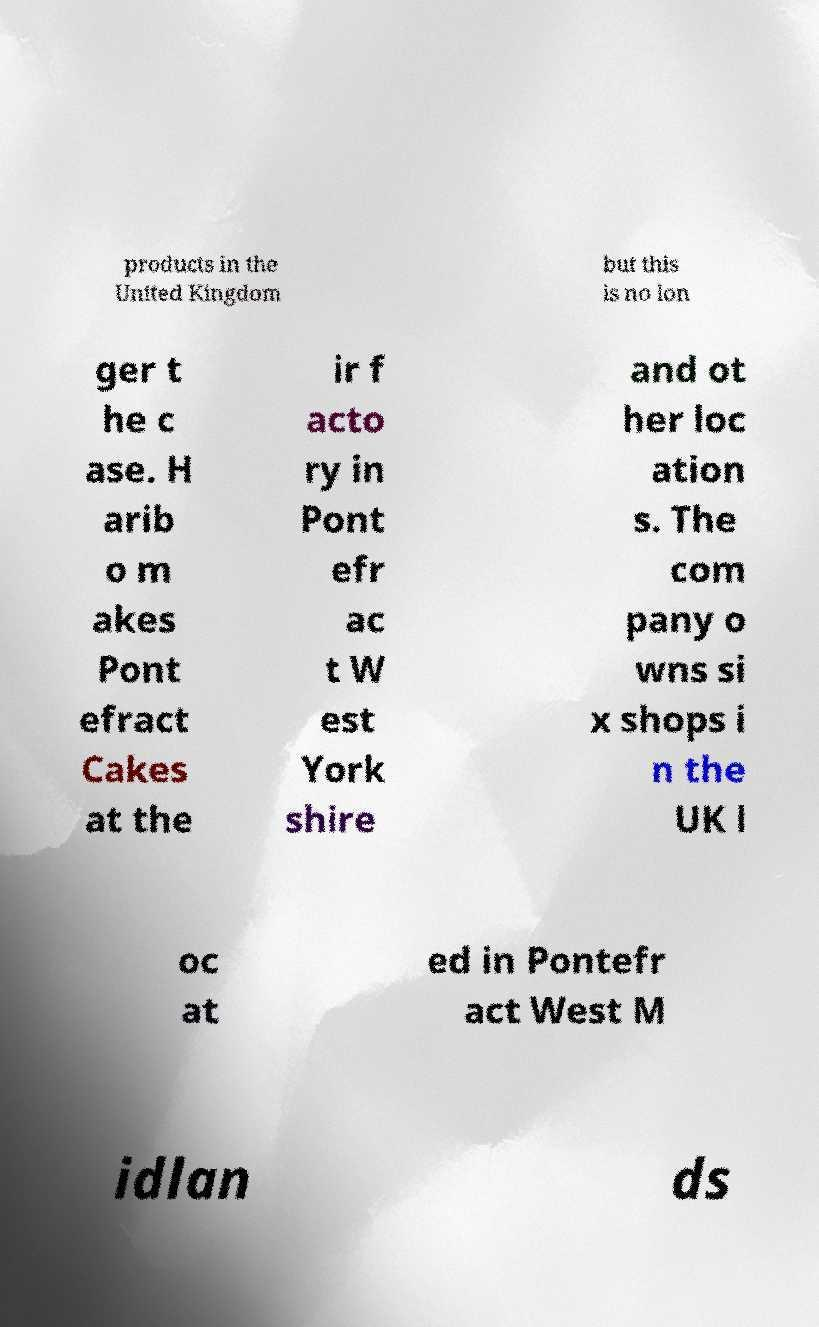Please identify and transcribe the text found in this image. products in the United Kingdom but this is no lon ger t he c ase. H arib o m akes Pont efract Cakes at the ir f acto ry in Pont efr ac t W est York shire and ot her loc ation s. The com pany o wns si x shops i n the UK l oc at ed in Pontefr act West M idlan ds 